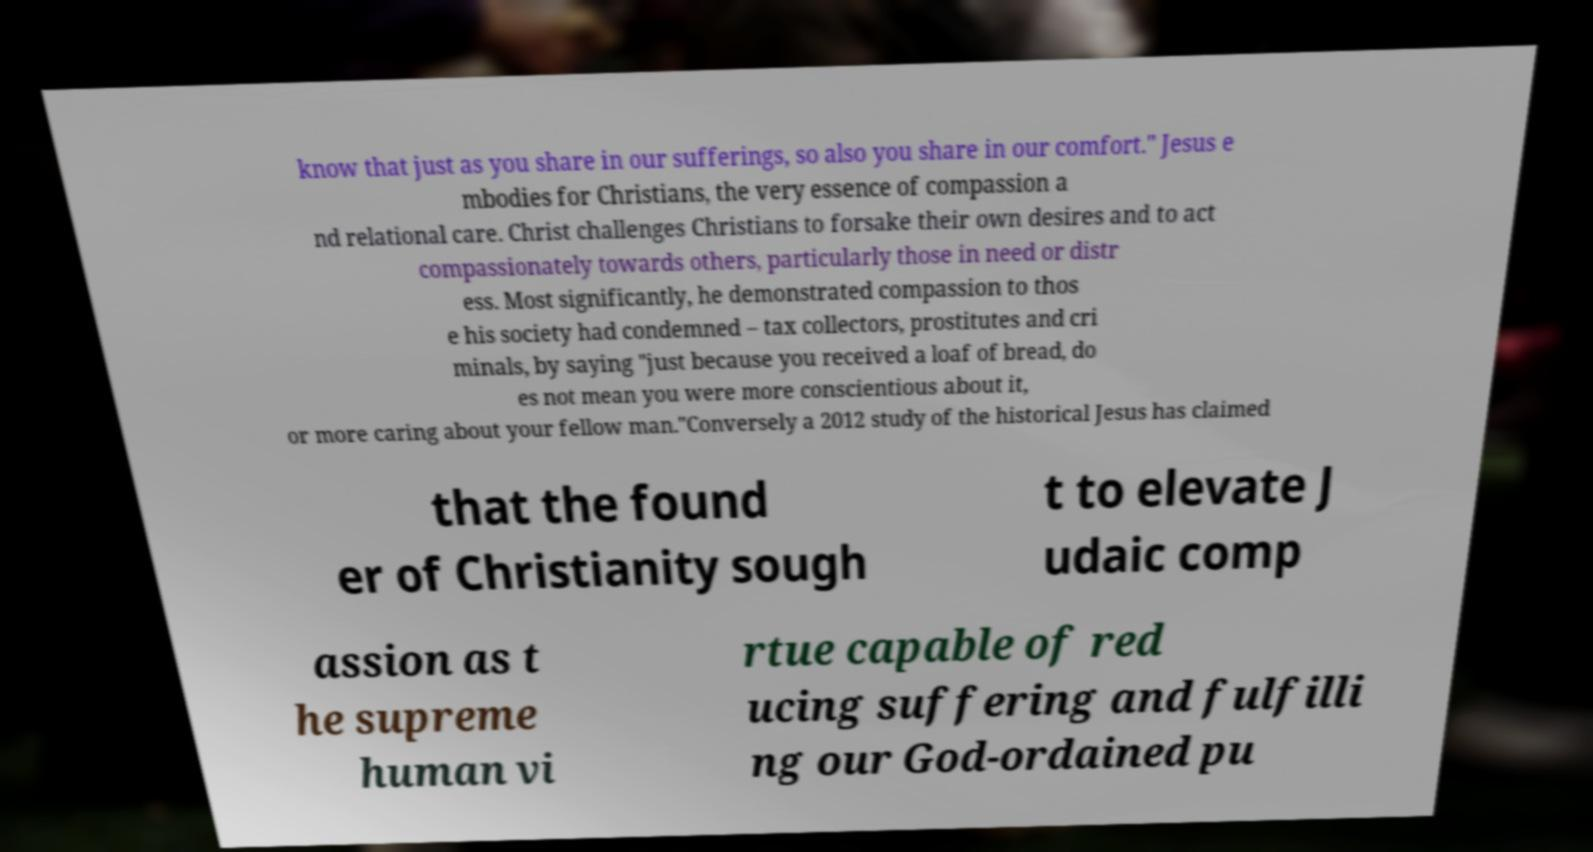Could you assist in decoding the text presented in this image and type it out clearly? know that just as you share in our sufferings, so also you share in our comfort." Jesus e mbodies for Christians, the very essence of compassion a nd relational care. Christ challenges Christians to forsake their own desires and to act compassionately towards others, particularly those in need or distr ess. Most significantly, he demonstrated compassion to thos e his society had condemned – tax collectors, prostitutes and cri minals, by saying "just because you received a loaf of bread, do es not mean you were more conscientious about it, or more caring about your fellow man."Conversely a 2012 study of the historical Jesus has claimed that the found er of Christianity sough t to elevate J udaic comp assion as t he supreme human vi rtue capable of red ucing suffering and fulfilli ng our God-ordained pu 